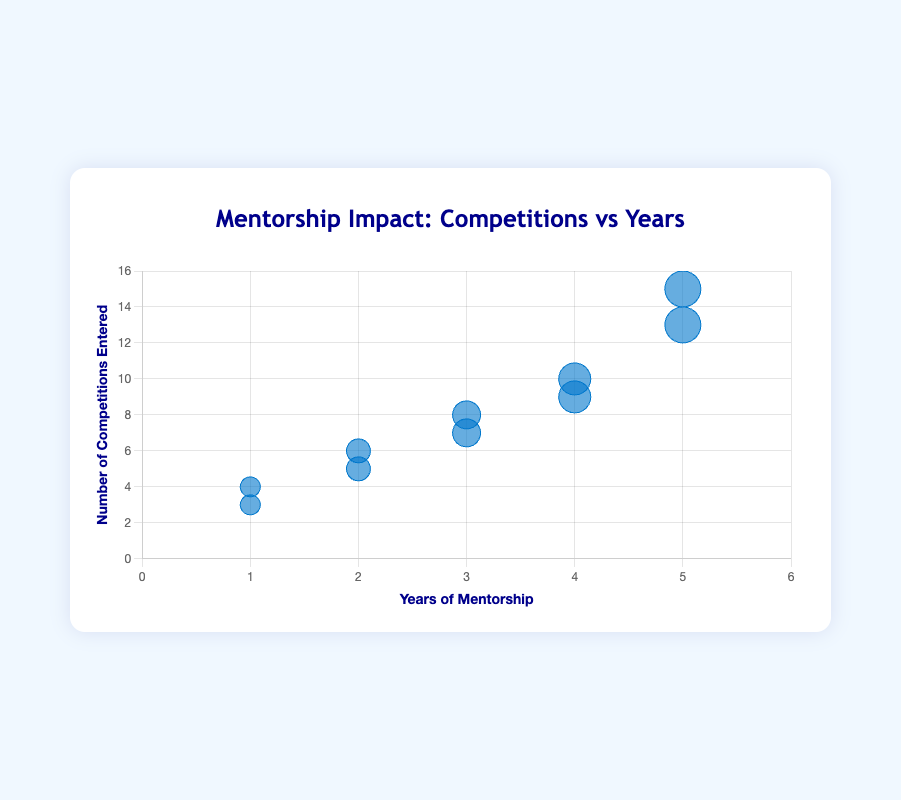what is the title of the chart? The title of the chart is written at the top of the figure. It reads "Mentorship Impact: Competitions vs Years."
Answer: Mentorship Impact: Competitions vs Years how many mentees have more than 4 years of mentorship? From the figure, we see data points corresponding to 5 years of mentorship for Evan Miller and Jane Wilson, and 4 years of mentorship for Diana Evans and Ian Thompson. That makes a total of 4 mentees.
Answer: 4 what are the highest and lowest number of competitions entered? The y-axis provides the number of competitions entered. From the data points, we see the highest is Evan Miller with 15 competitions, and the lowest is Alice Johnson with 3 competitions.
Answer: 15 and 3 which mentees have entered exactly 5 competitions? On the chart, find the dots positioned at y = 5. The tooltip or hover-over will indicate the names. Bob Smith has entered 5 competitions.
Answer: Bob Smith how does the number of competitions entered change with increasing years of mentorship? Observing the trend in the bubble chart, we see that as the x-value (years of mentorship) increases, the y-value (number of competitions entered) generally increases too.
Answer: Increases who entered 9 competitions and how long were they mentored? Hovering over the bubble or checking for the data point at y = 9, x = 4 indicates that Ian Thompson entered 9 competitions with 4 years of mentorship.
Answer: Ian Thompson, 4 years how many mentees have entered more than 10 competitions? Checking the y-axis for points higher than 10, we see two data points above 10: Evan Miller (15 competitions) and Jane Wilson (13 competitions).
Answer: 2 compare the number of competitions entered by mentees with 1 year and those with 5 years of mentorship. Mentees with 1 year (Alice Johnson and Fiona Green) entered 3 and 4 competitions respectively, totaling 3 + 4 = 7. Mentees with 5 years (Evan Miller and Jane Wilson) entered 15 and 13 competitions, totaling 15 + 13 = 28.
Answer: 7 and 28 who are the mentees with bubbles of the same size, and what does that size represent? Bubbles of the same size indicate the same number of competitions entered. Look for data points with the same radius. Alice Johnson and Fiona Green's bubbles have the same size as they both entered similar competitions (1 year mentorship).
Answer: Alice Johnson and Fiona Green, same number of competitions with the same mentorship year which mentee shows the greatest improvement in competitions entered over the years? To determine this, consider the slope created by the bubbles, indicating the steepest climb. Comparing all, Evan Miller with 15 competitions at 5 years, and Bob Smith with 5 competitions at 2 years show strong improvement. Evan's improvement is the steepest.
Answer: Evan Miller 